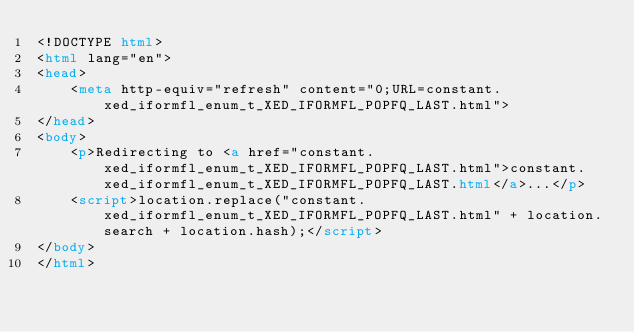Convert code to text. <code><loc_0><loc_0><loc_500><loc_500><_HTML_><!DOCTYPE html>
<html lang="en">
<head>
    <meta http-equiv="refresh" content="0;URL=constant.xed_iformfl_enum_t_XED_IFORMFL_POPFQ_LAST.html">
</head>
<body>
    <p>Redirecting to <a href="constant.xed_iformfl_enum_t_XED_IFORMFL_POPFQ_LAST.html">constant.xed_iformfl_enum_t_XED_IFORMFL_POPFQ_LAST.html</a>...</p>
    <script>location.replace("constant.xed_iformfl_enum_t_XED_IFORMFL_POPFQ_LAST.html" + location.search + location.hash);</script>
</body>
</html></code> 